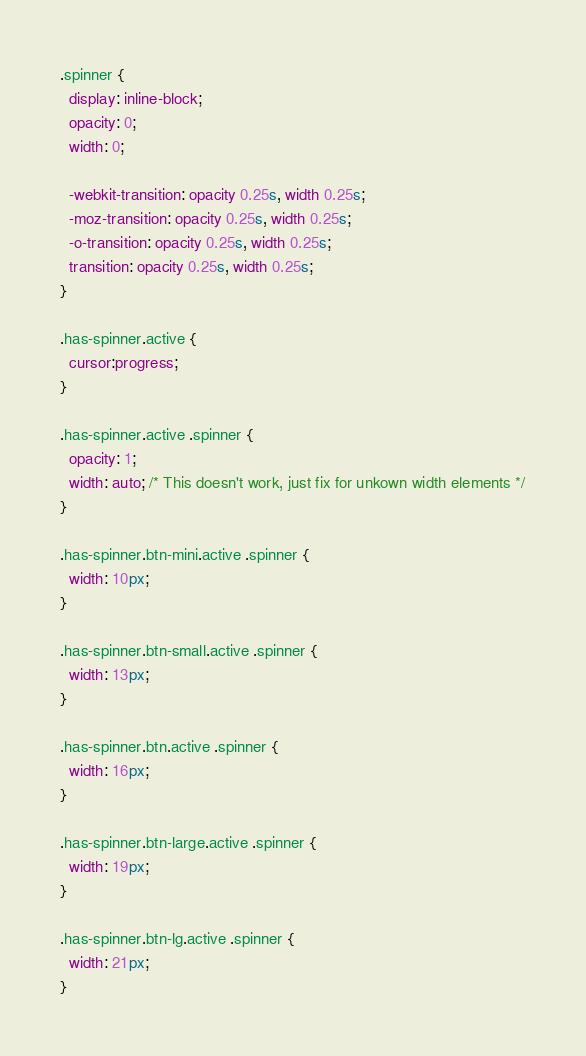Convert code to text. <code><loc_0><loc_0><loc_500><loc_500><_CSS_>.spinner {
  display: inline-block;
  opacity: 0;
  width: 0;

  -webkit-transition: opacity 0.25s, width 0.25s;
  -moz-transition: opacity 0.25s, width 0.25s;
  -o-transition: opacity 0.25s, width 0.25s;
  transition: opacity 0.25s, width 0.25s;
}

.has-spinner.active {
  cursor:progress;
}

.has-spinner.active .spinner {
  opacity: 1;
  width: auto; /* This doesn't work, just fix for unkown width elements */
}

.has-spinner.btn-mini.active .spinner {
  width: 10px;
}

.has-spinner.btn-small.active .spinner {
  width: 13px;
}

.has-spinner.btn.active .spinner {
  width: 16px;
}

.has-spinner.btn-large.active .spinner {
  width: 19px;
}

.has-spinner.btn-lg.active .spinner {
  width: 21px;
}
</code> 